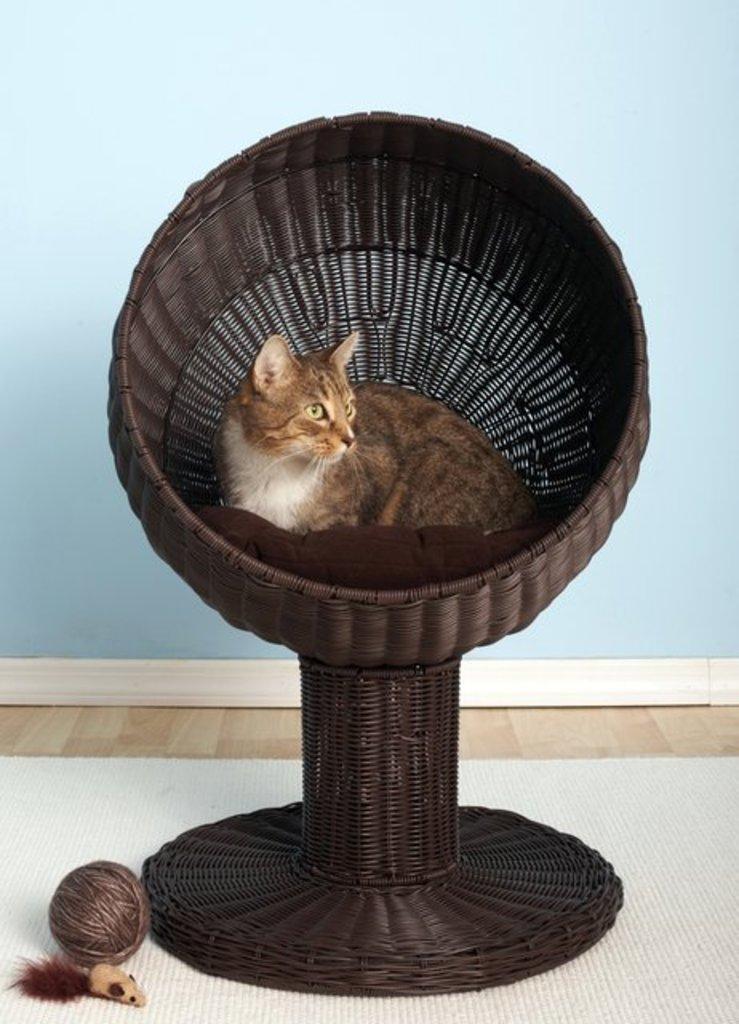Please provide a concise description of this image. There is a cat sitting in a basket which on the white color surface on which, there is thread bundle and a toy. In the background, there is blue color wall. 